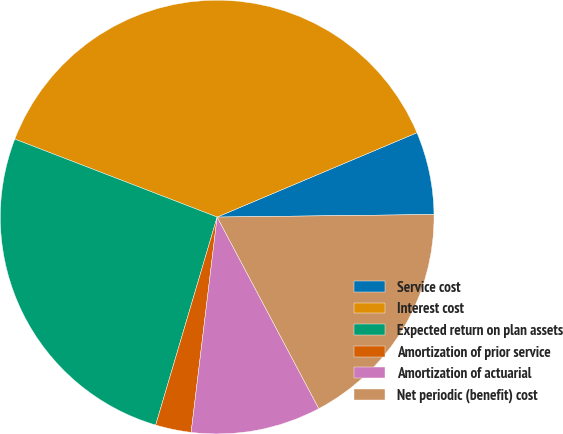Convert chart. <chart><loc_0><loc_0><loc_500><loc_500><pie_chart><fcel>Service cost<fcel>Interest cost<fcel>Expected return on plan assets<fcel>Amortization of prior service<fcel>Amortization of actuarial<fcel>Net periodic (benefit) cost<nl><fcel>6.17%<fcel>37.79%<fcel>26.28%<fcel>2.66%<fcel>9.68%<fcel>17.42%<nl></chart> 